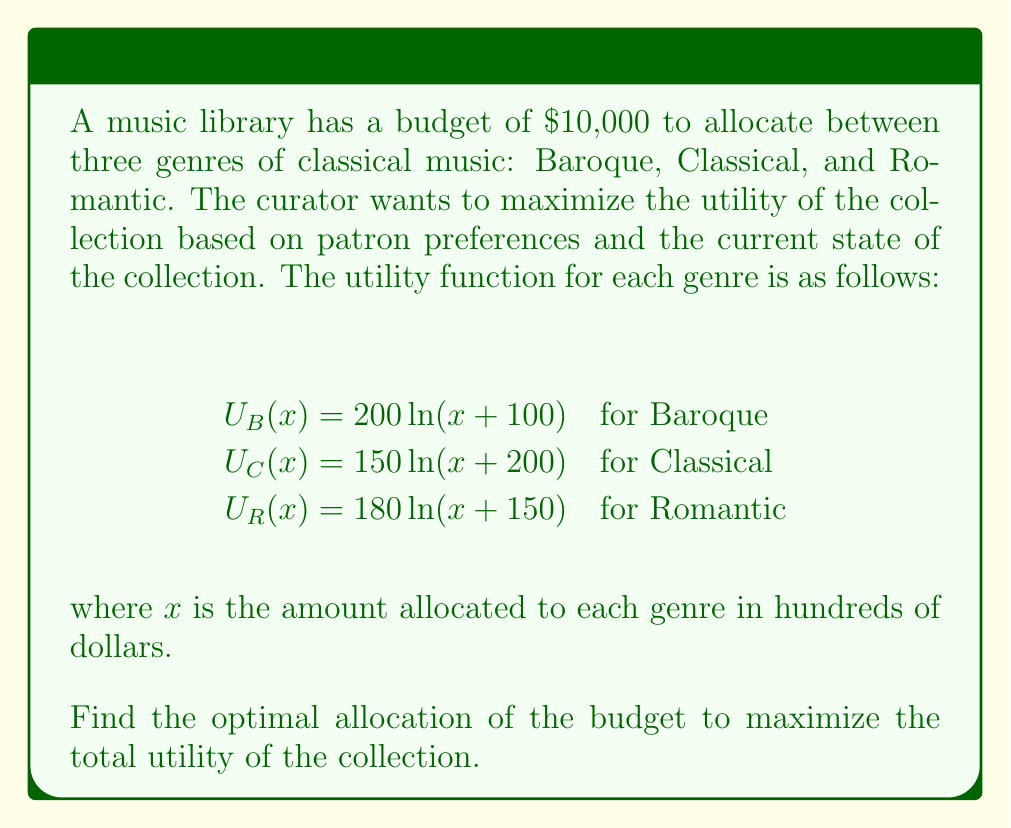Can you answer this question? To solve this problem, we'll use the method of Lagrange multipliers, as we're maximizing a function subject to a constraint.

1) First, let's define our objective function:
   $$U(x_B, x_C, x_R) = 200\ln(x_B+1) + 150\ln(x_C+2) + 180\ln(x_R+1.5)$$

2) Our constraint is:
   $$x_B + x_C + x_R = 100$$ (since the budget is in hundreds of dollars)

3) We form the Lagrangian:
   $$L = 200\ln(x_B+1) + 150\ln(x_C+2) + 180\ln(x_R+1.5) - \lambda(x_B + x_C + x_R - 100)$$

4) Now, we take partial derivatives and set them equal to zero:

   $$\frac{\partial L}{\partial x_B} = \frac{200}{x_B+1} - \lambda = 0$$
   $$\frac{\partial L}{\partial x_C} = \frac{150}{x_C+2} - \lambda = 0$$
   $$\frac{\partial L}{\partial x_R} = \frac{180}{x_R+1.5} - \lambda = 0$$
   $$\frac{\partial L}{\partial \lambda} = x_B + x_C + x_R - 100 = 0$$

5) From the first three equations:
   $$x_B = \frac{200}{\lambda} - 1$$
   $$x_C = \frac{150}{\lambda} - 2$$
   $$x_R = \frac{180}{\lambda} - 1.5$$

6) Substituting these into the constraint equation:
   $$(\frac{200}{\lambda} - 1) + (\frac{150}{\lambda} - 2) + (\frac{180}{\lambda} - 1.5) = 100$$

7) Simplifying:
   $$\frac{530}{\lambda} - 4.5 = 100$$
   $$\frac{530}{\lambda} = 104.5$$
   $$\lambda = \frac{530}{104.5} \approx 5.0718$$

8) Now we can solve for $x_B$, $x_C$, and $x_R$:
   $$x_B = \frac{200}{5.0718} - 1 \approx 38.4$$
   $$x_C = \frac{150}{5.0718} - 2 \approx 27.6$$
   $$x_R = \frac{180}{5.0718} - 1.5 \approx 34.0$$

9) Rounding to the nearest hundred dollars:
   Baroque: $3,800
   Classical: $2,800
   Romantic: $3,400
Answer: The optimal allocation of the $10,000 budget is:
Baroque: $3,800
Classical: $2,800
Romantic: $3,400 